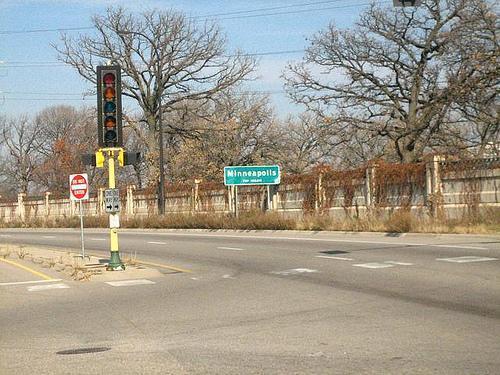How many people are carrying a load on their shoulder?
Give a very brief answer. 0. 